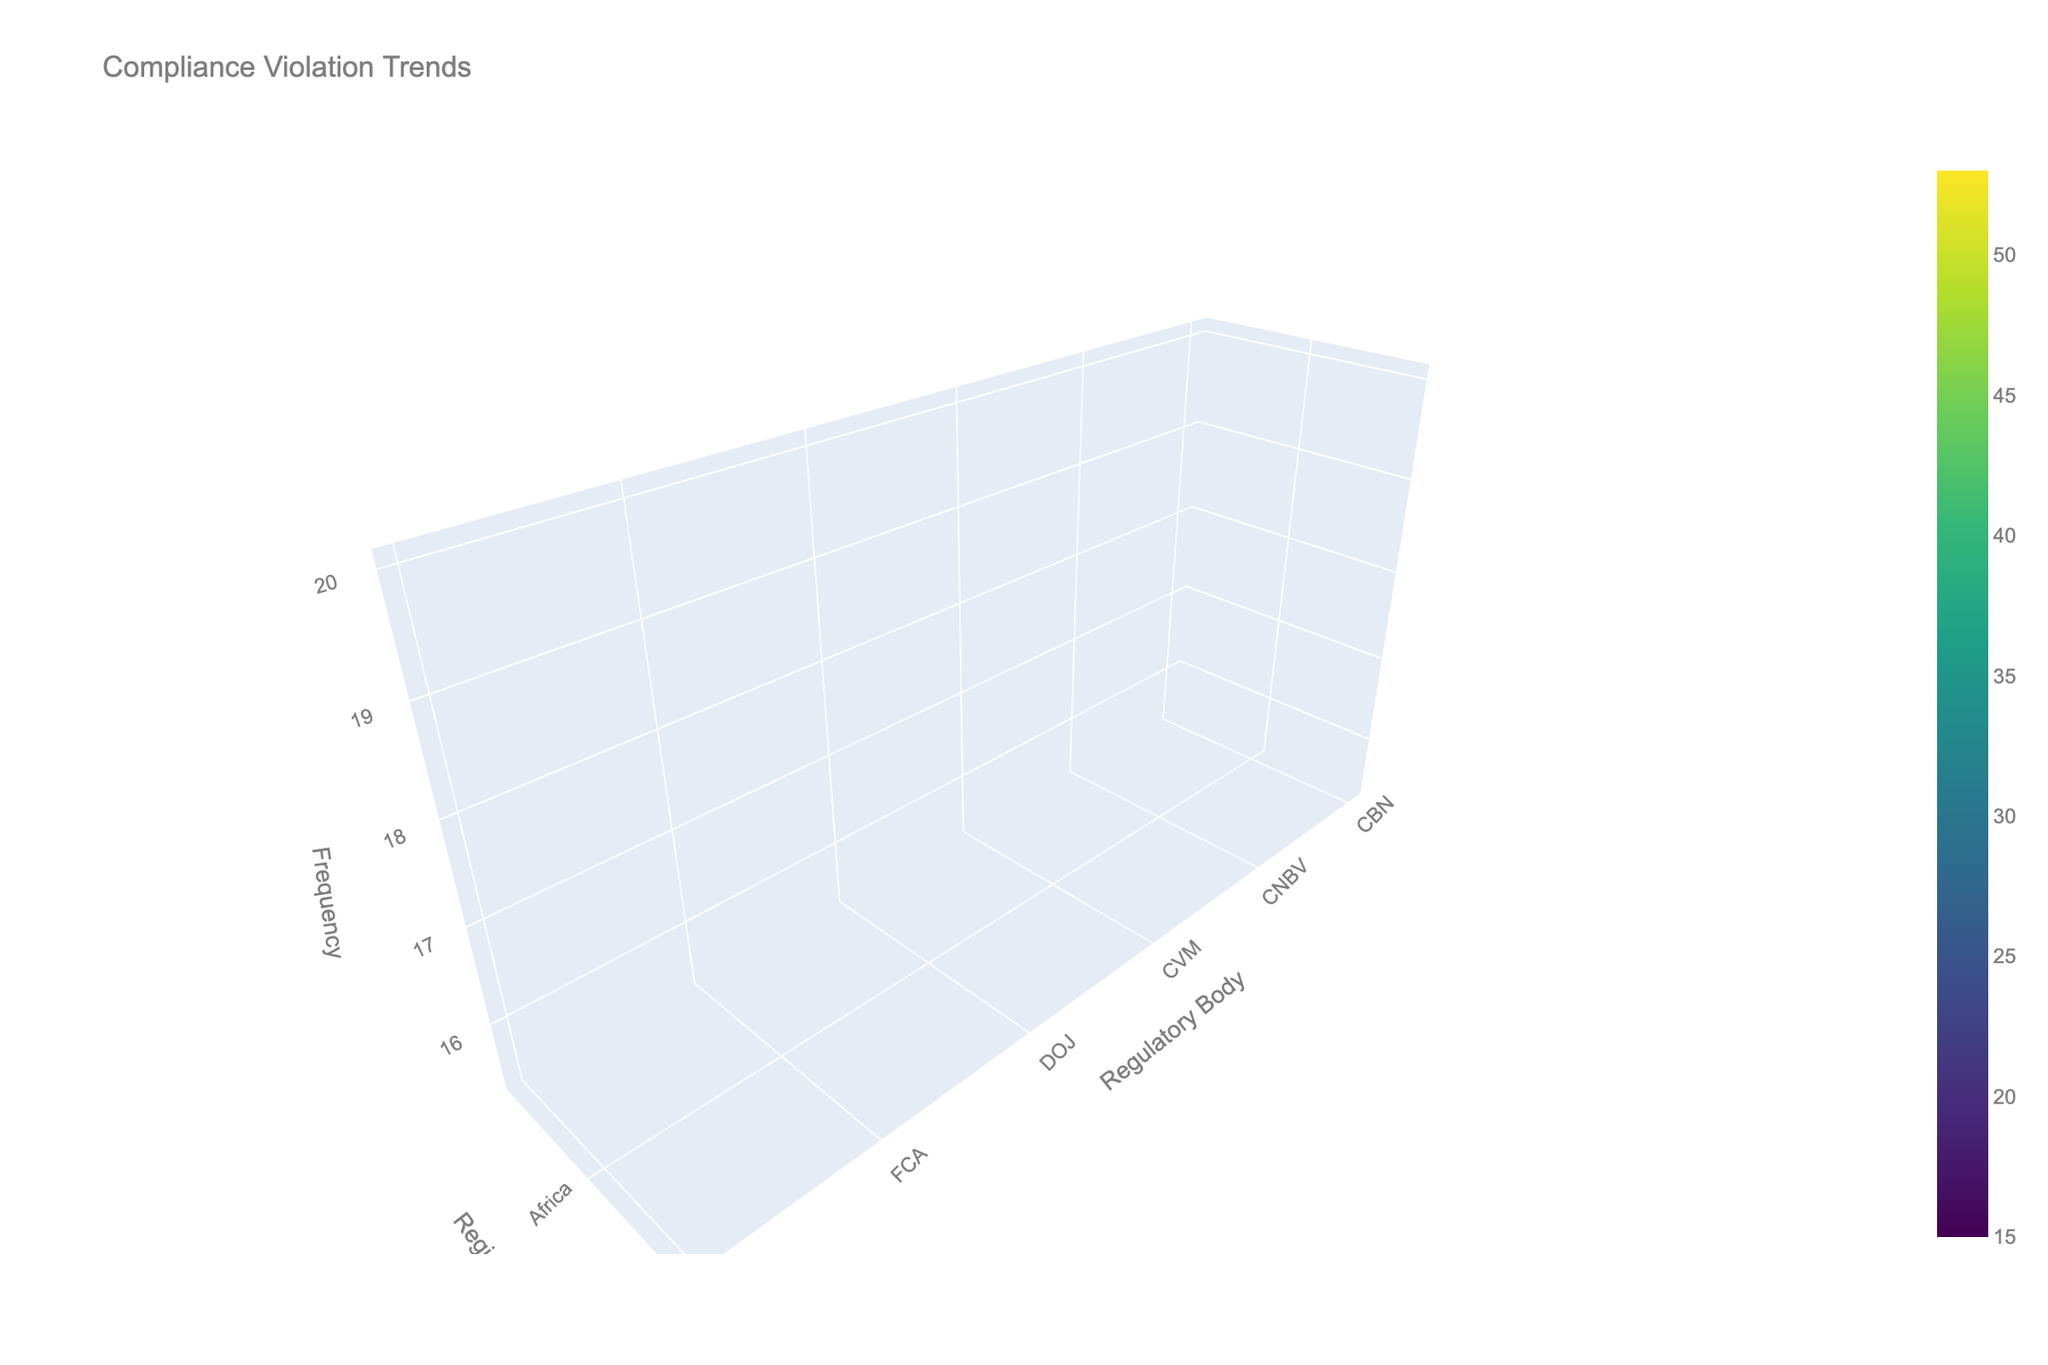What is the peak point of compliance violation frequency in North America? A peak point is a maximum value in a certain region. By looking at North America on the y-axis and finding the highest point on the z-axis, the maximum compliance violation frequency is with the SEC.
Answer: 42 Which regulatory body in Europe sees the highest frequency of violations? To determine the highest frequency of violations in Europe, identify the regulatory body on the x-axis associated with the highest point on the z-axis within the Europe region. The GDPR has the highest frequency.
Answer: GDPR Are there more violations in Asia or Latin America? Check the average height of the surface plot in the Asia and Latin America regions. Adding the frequencies in Asia and comparing them to those in Latin America shows that Asia has a higher average frequency.
Answer: Asia Which region has the lowest pattern of violations across all regulatory bodies? To identify the lowest pattern, look for the region with the consistently lowest points on the z-axis. Africa consistently has lower values compared to other regions.
Answer: Africa What is the average violation frequency for the Middle East regulatory bodies? Adding the violation frequencies (30, 25, 21) for the Middle East regulatory bodies and dividing by the number of bodies (3), the average is (30 + 25 + 21) / 3 = 25.3.
Answer: 25.3 What is the difference in violation frequency between SEC in North America and GDPR in Europe? Subtract the frequency for GDPR (53) from the frequency of the SEC (42) to get the difference: 53 - 42 = 11.
Answer: 11 Which regulatory body has the highest variance in violation frequencies across all regions? Identify the body that shows the most significant changes in z-value (violation frequency) across different y-values (regions). The bodies need to be compared in terms of frequency variance.
Answer: GDPR How do violation frequencies of Anti-Corruption in North America compare to Corporate Disclosure in the Middle East? Compare the heights of the surface at the position corresponding to Anti-Corruption in North America (28) and Corporate Disclosure in the Middle East (25). North America is higher.
Answer: North America Which type of compliance violation is most frequent in Asia? Look at the highest z-value in Asia and find which violation type it corresponds to. Money Laundering has the highest frequency at 39.
Answer: Money Laundering Do violations in the European region generally show higher or lower frequencies compared to the African region? Compare the average heights of the European and African regions along the y-axis. Europe shows generally higher frequencies compared to Africa.
Answer: Higher 